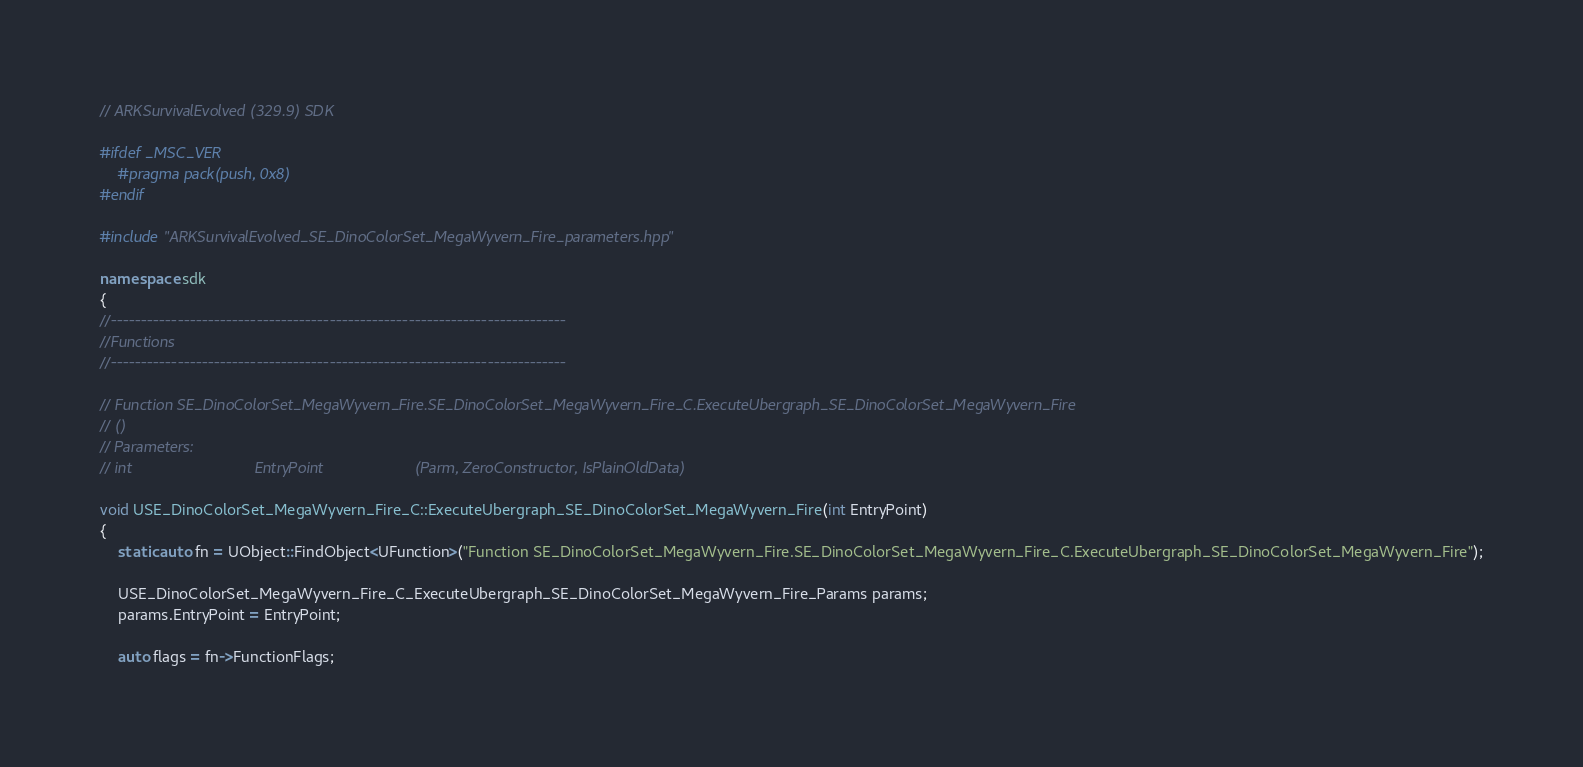Convert code to text. <code><loc_0><loc_0><loc_500><loc_500><_C++_>// ARKSurvivalEvolved (329.9) SDK

#ifdef _MSC_VER
	#pragma pack(push, 0x8)
#endif

#include "ARKSurvivalEvolved_SE_DinoColorSet_MegaWyvern_Fire_parameters.hpp"

namespace sdk
{
//---------------------------------------------------------------------------
//Functions
//---------------------------------------------------------------------------

// Function SE_DinoColorSet_MegaWyvern_Fire.SE_DinoColorSet_MegaWyvern_Fire_C.ExecuteUbergraph_SE_DinoColorSet_MegaWyvern_Fire
// ()
// Parameters:
// int                            EntryPoint                     (Parm, ZeroConstructor, IsPlainOldData)

void USE_DinoColorSet_MegaWyvern_Fire_C::ExecuteUbergraph_SE_DinoColorSet_MegaWyvern_Fire(int EntryPoint)
{
	static auto fn = UObject::FindObject<UFunction>("Function SE_DinoColorSet_MegaWyvern_Fire.SE_DinoColorSet_MegaWyvern_Fire_C.ExecuteUbergraph_SE_DinoColorSet_MegaWyvern_Fire");

	USE_DinoColorSet_MegaWyvern_Fire_C_ExecuteUbergraph_SE_DinoColorSet_MegaWyvern_Fire_Params params;
	params.EntryPoint = EntryPoint;

	auto flags = fn->FunctionFlags;
</code> 